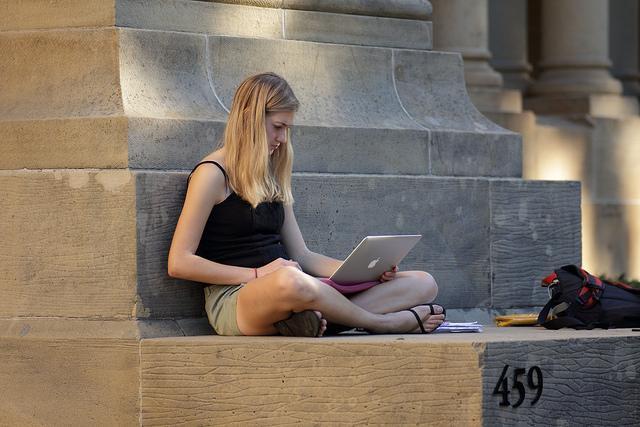How might this person easily look up the phone number for a taxi?
From the following four choices, select the correct answer to address the question.
Options: Check purse, ask passersby, google it, yellow pages. Google it. 